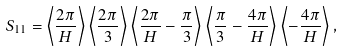<formula> <loc_0><loc_0><loc_500><loc_500>S _ { 1 1 } = \left \langle \frac { 2 \pi } { H } \right \rangle \left \langle \frac { 2 \pi } { 3 } \right \rangle \left \langle \frac { 2 \pi } { H } - \frac { \pi } { 3 } \right \rangle \left \langle \frac { \pi } { 3 } - \frac { 4 \pi } { H } \right \rangle \left \langle - \frac { 4 \pi } { H } \right \rangle ,</formula> 